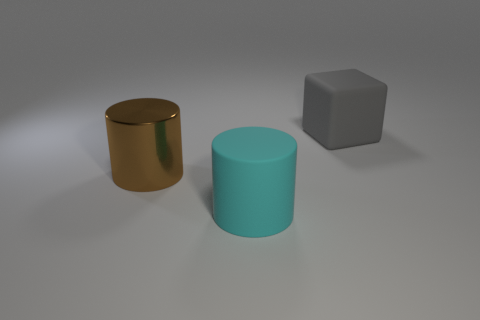Add 1 large cyan rubber objects. How many objects exist? 4 Subtract all cylinders. How many objects are left? 1 Subtract all rubber cylinders. Subtract all cyan rubber objects. How many objects are left? 1 Add 3 large rubber blocks. How many large rubber blocks are left? 4 Add 2 small brown rubber spheres. How many small brown rubber spheres exist? 2 Subtract 0 purple blocks. How many objects are left? 3 